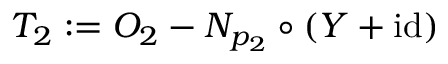Convert formula to latex. <formula><loc_0><loc_0><loc_500><loc_500>T _ { 2 } \colon = O _ { 2 } - N _ { p _ { 2 } } \circ ( Y + i d )</formula> 